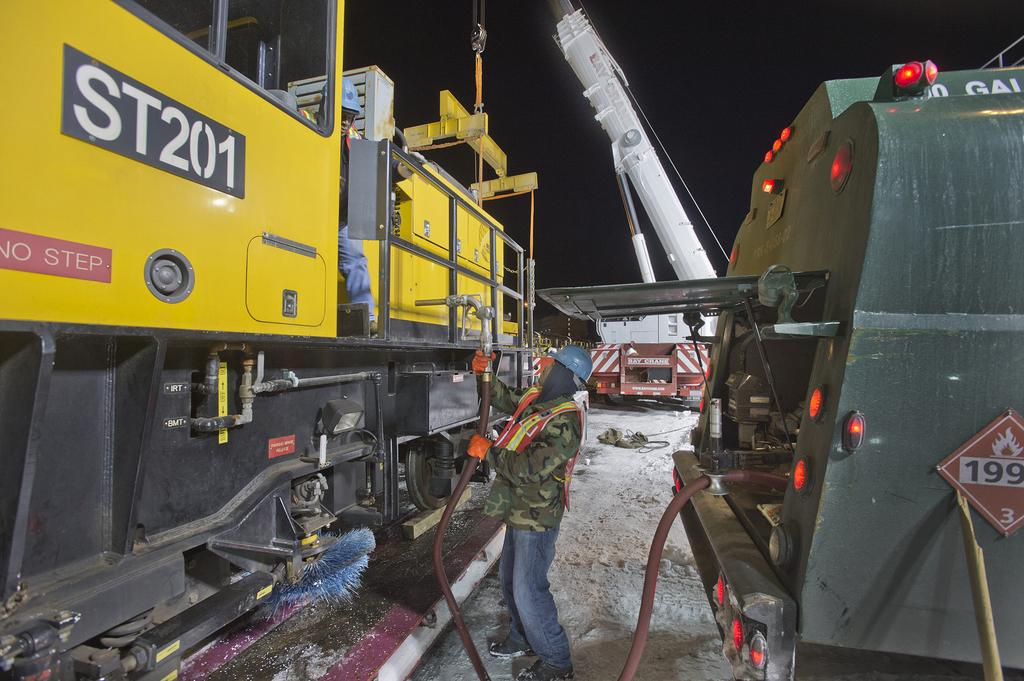<image>
Give a short and clear explanation of the subsequent image. A large yellow piece of machinery that says no step and ST 201 on it. 